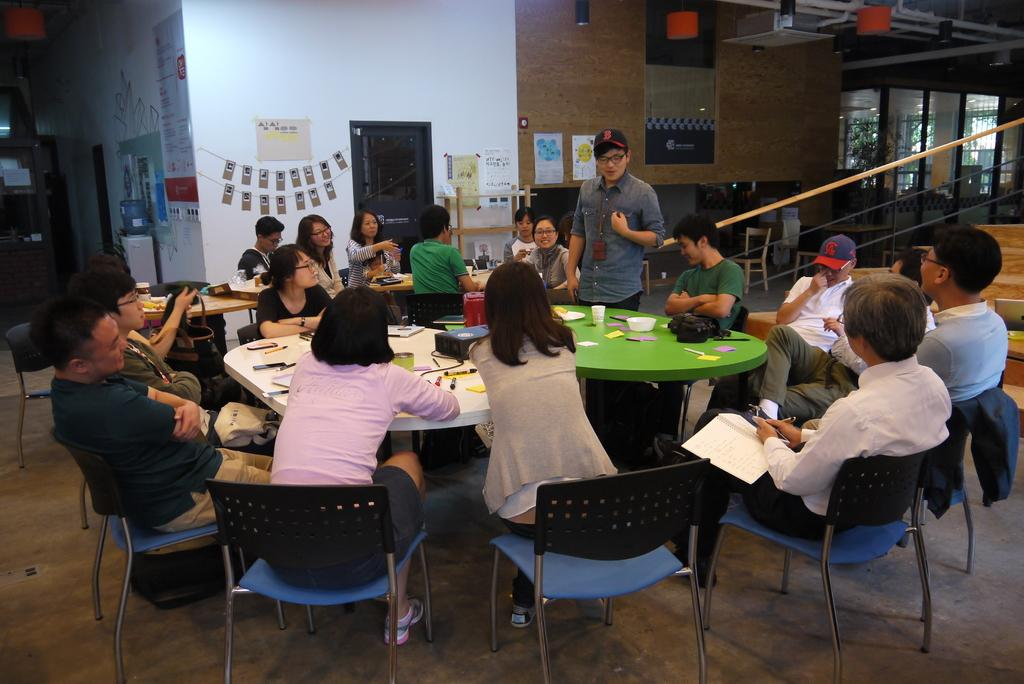How many people are visible in the image? There are many people in the image. What are the people doing in the image? The people are sitting on chairs. What is in front of the chairs? There is a table in front of the chairs. What can be seen on the table? There are many items on the table. Can you see a rat hiding under one of the chairs in the image? There is no rat present in the image. What type of yam is being served on the table in the image? There is no yam present in the image. 